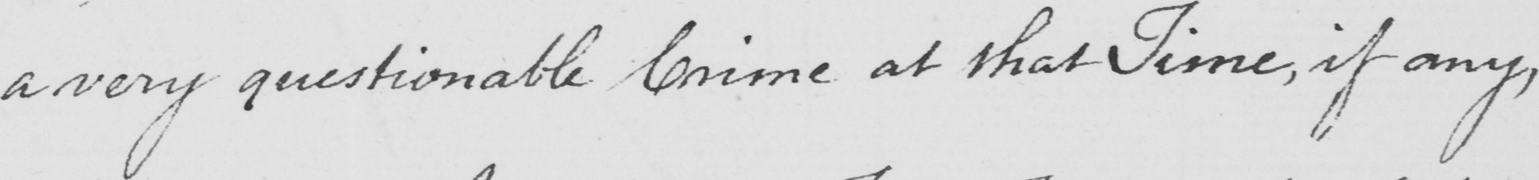Please provide the text content of this handwritten line. a very questionable Crime at that Time , if any , 